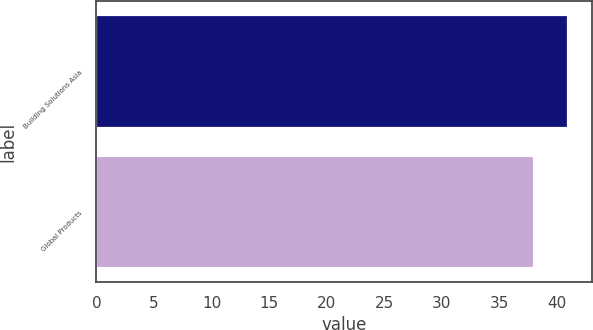<chart> <loc_0><loc_0><loc_500><loc_500><bar_chart><fcel>Building Solutions Asia<fcel>Global Products<nl><fcel>41<fcel>38<nl></chart> 